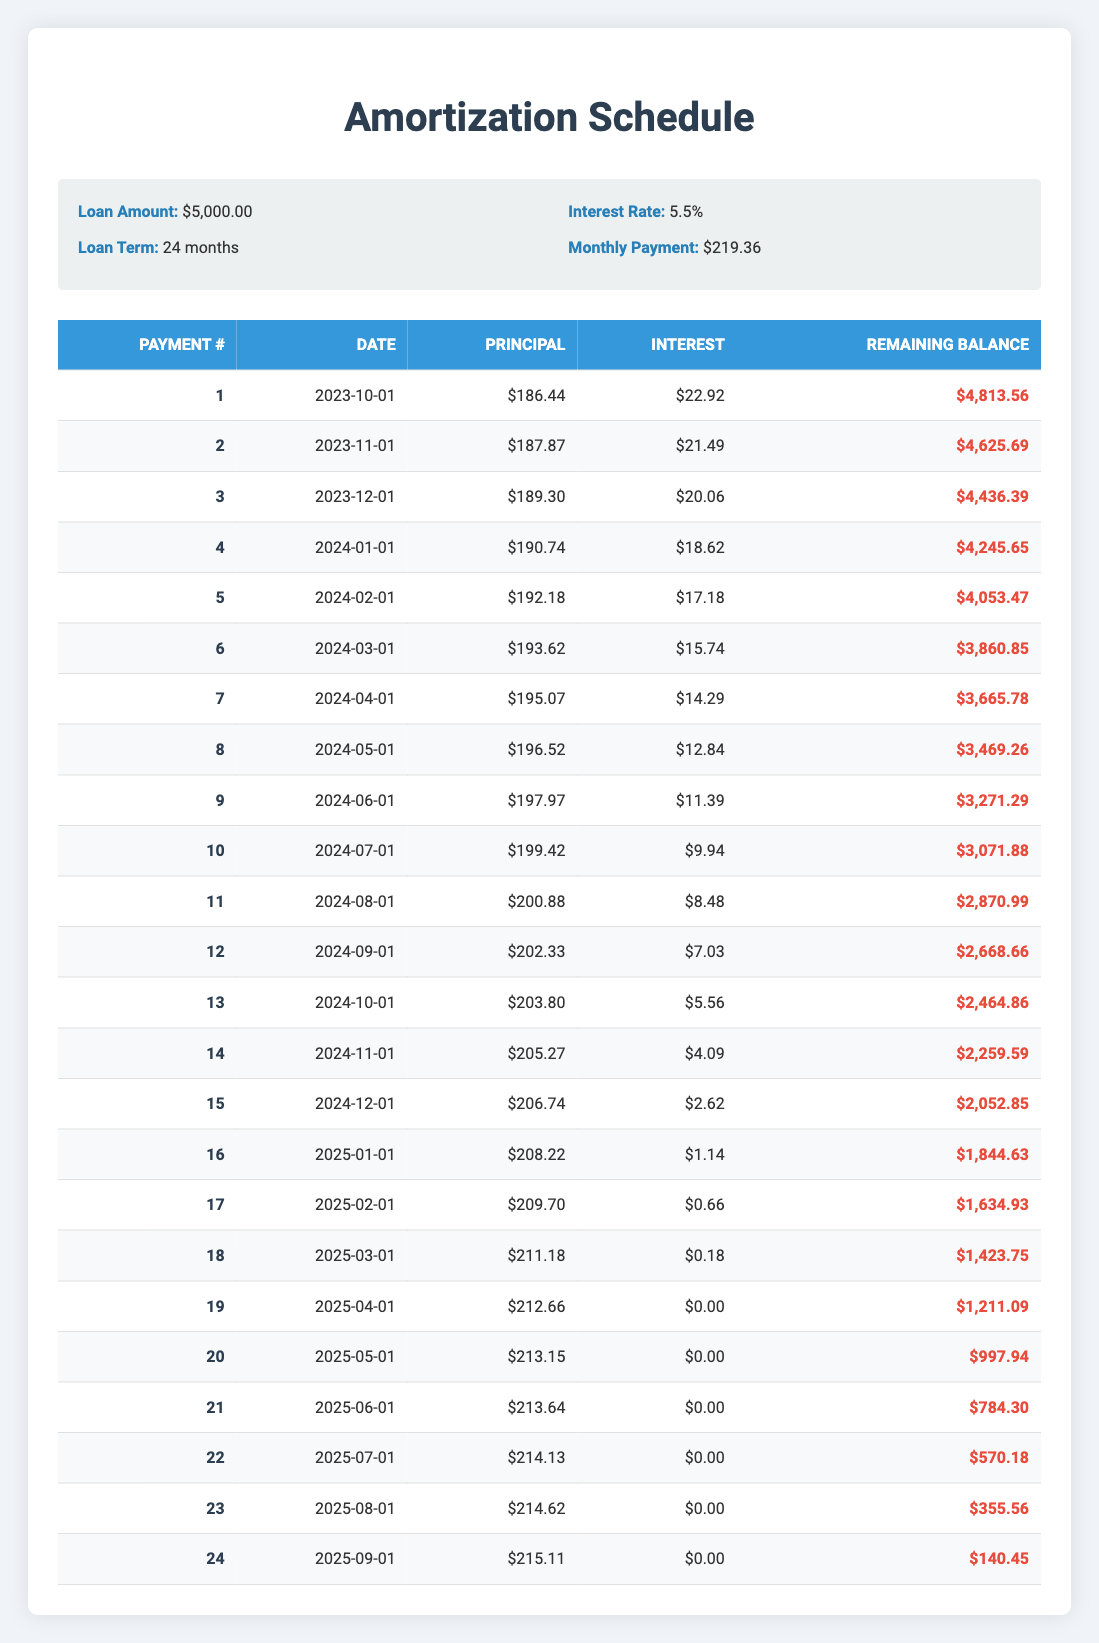What is the total principal payment made in the first three months? To find the total principal payment for the first three months, add the principal payments for each of the first three entries: $186.44 (Month 1) + $187.87 (Month 2) + $189.30 (Month 3) = $563.61.
Answer: 563.61 What is the remaining balance after the 12th payment? The remaining balance after the 12th payment is listed in the table, specifically in the row for the 12th payment, which shows a remaining balance of $2,668.66.
Answer: 2668.66 Did the interest payment decrease in every month? Looking at the interest payments for each month, there are instances where the interest decreases regularly, but after reviewing, there are no months where the interest payment increased. Therefore, it is true that the interest payment decreased consistently each month.
Answer: Yes What is the total interest paid after the loan term? To find the total interest paid over the loan term, sum up all the interest payments from each monthly payment. The total is $22.92 + $21.49 + $20.06 + $18.62 + $17.18 + $15.74 + $14.29 + $12.84 + $11.39 + $9.94 + $8.48 + $7.03 + $5.56 + $4.09 + $2.62 + $1.14 + $0.66 + $0.18 + $0 + $0 + $0 + $0 + $0 + $0 = $134.14.
Answer: 134.14 What was the monthly payment amount? The monthly payment amount is provided in the loan details section of the table, which states that the monthly payment is $219.36.
Answer: 219.36 How much more principal was paid in the 12th month than in the 1st month? To determine how much more principal was paid in the 12th month compared to the 1st month, find the principal payment for both months: Month 1 was $186.44 and Month 12 was $202.33. The difference is $202.33 - $186.44 = $15.89.
Answer: 15.89 What is the average remaining balance after every 6 payments? Calculate the remaining balance after every 6 payments, which are $4,813.56, $4,625.69, $4,436.39, $4,245.65, $4,053.47, and $3,860.85. Sum these remaining balances and divide by 6: ($4,813.56 + $4,625.69 + $4,436.39 + $4,245.65 + $4,053.47 + $3,860.85) / 6 = $4,336.27.
Answer: 4336.27 What is the payment number when the interest payment goes to zero? By reviewing the table, the interest payment reaches zero at payment number 19. This is confirmed by looking at the interest payments in the corresponding row.
Answer: 19 What is the highest principal payment made in the schedule? The highest principal payment listed in the schedule occurs during the final payment, which is $215.11. This is seen by evaluating the principal payments from each row and identifying the maximum value.
Answer: 215.11 